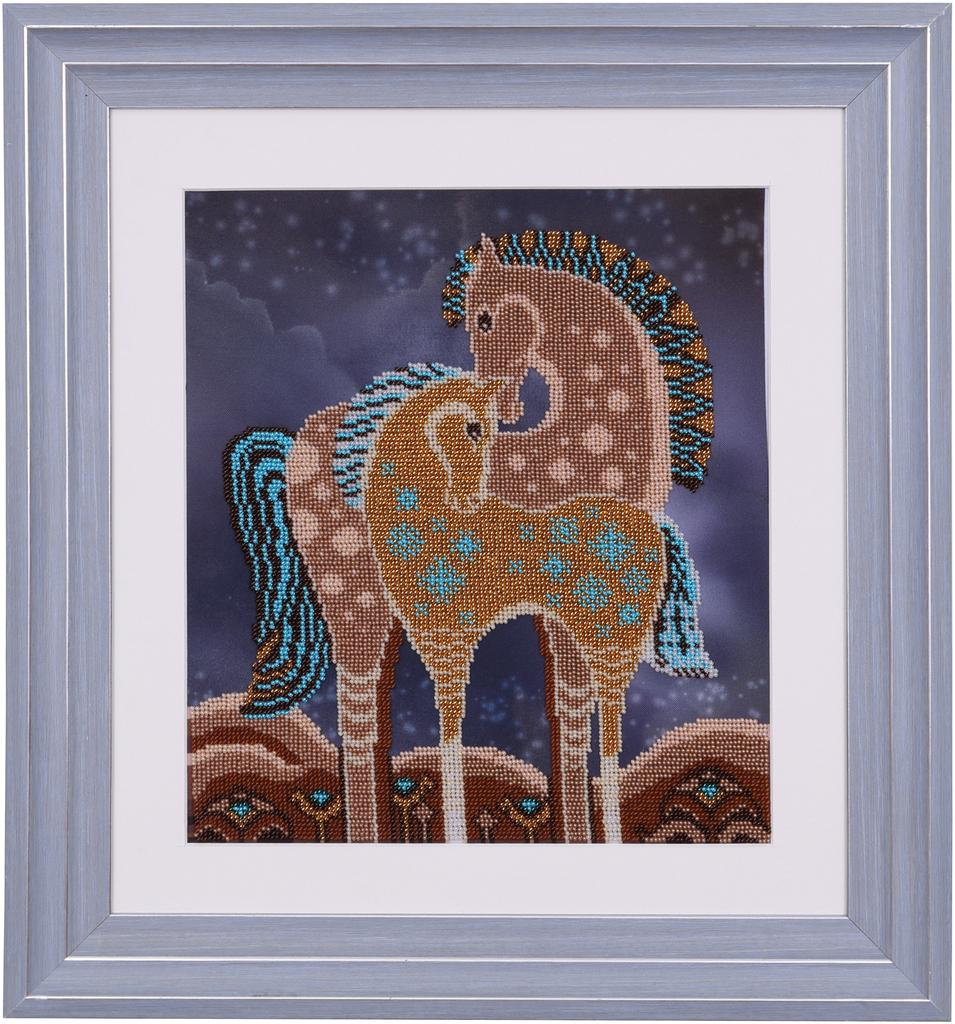What object is present in the image that typically holds a picture? There is a photo frame in the image. What type of image is displayed in the photo frame? The photo frame contains a picture of horses. What is the profit made from the horses in the image? There is no information about profit or any financial aspect related to the horses in the image. 